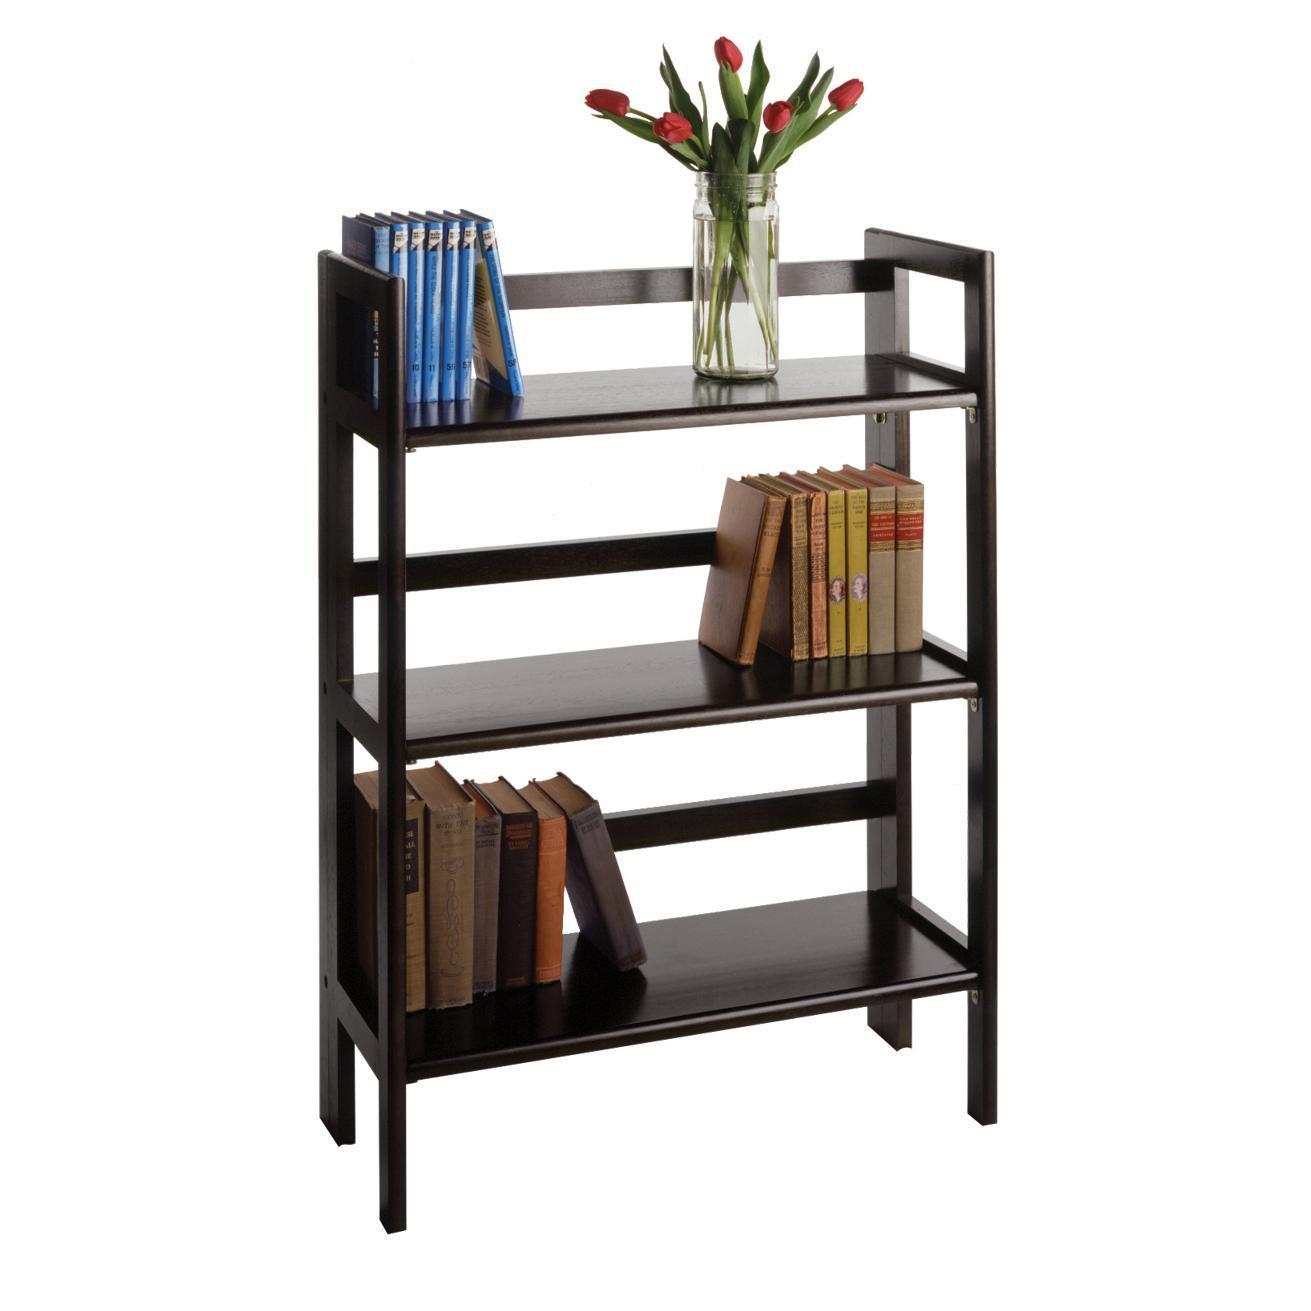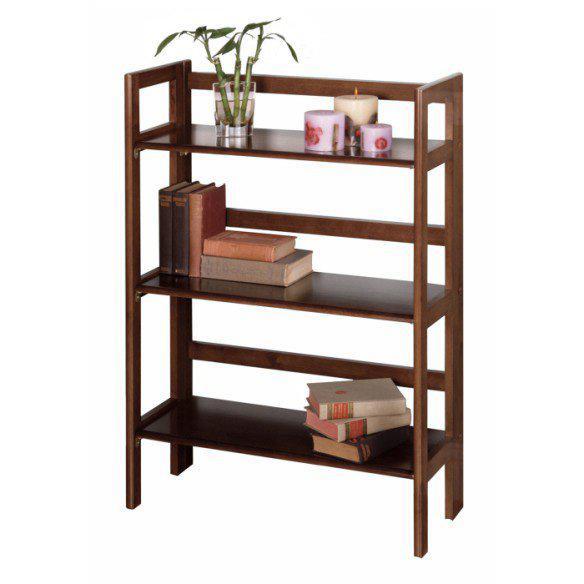The first image is the image on the left, the second image is the image on the right. For the images displayed, is the sentence "at least one bookshelf is empty" factually correct? Answer yes or no. No. The first image is the image on the left, the second image is the image on the right. Examine the images to the left and right. Is the description "One of the shelving units is up against a wall." accurate? Answer yes or no. No. 